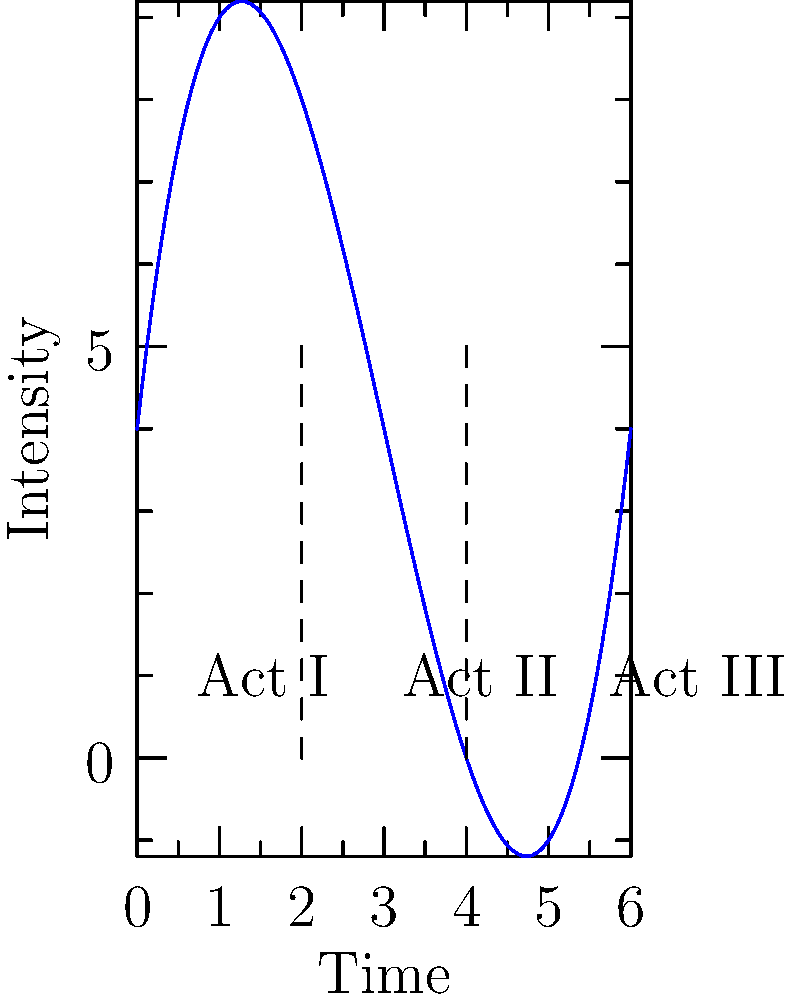Analyze the structure of this three-act screenplay represented by the line graph. How does the intensity of the plot compare between Act II and Act III, and what might this suggest about the screenplay's potential to outshine Rumman Rashid Khan's work? To analyze the structure and compare the intensity between Act II and Act III:

1. Identify the acts:
   - Act I: 0 to 2 on the x-axis
   - Act II: 2 to 4 on the x-axis
   - Act III: 4 to 6 on the x-axis

2. Observe the curve's behavior:
   - Act I: Starts low, gradually increases
   - Act II: Reaches a peak, then declines
   - Act III: Starts low, rapidly increases to the highest point

3. Compare Act II and Act III:
   - Act II has a higher starting point but lower peak
   - Act III has a lower starting point but reaches the highest peak

4. Interpret the structure:
   - Act II builds tension but doesn't resolve it
   - Act III has the most dramatic increase, leading to the climax

5. Potential to outshine Rumman Rashid Khan:
   - The strong Act III suggests a powerful climax and resolution
   - The contrast between Acts II and III creates a more dynamic narrative arc
   - The rapid intensity increase in Act III may create a more memorable ending

This structure indicates a screenplay with a powerful final act, potentially creating a more impactful and memorable experience for the audience compared to Rumman Rashid Khan's work.
Answer: Act III has a higher peak intensity than Act II, suggesting a powerful climax that could potentially outshine Rumman Rashid Khan's work. 